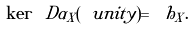Convert formula to latex. <formula><loc_0><loc_0><loc_500><loc_500>\ker \ D \alpha _ { X } ( \ u n i t y ) = \ h _ { X } .</formula> 